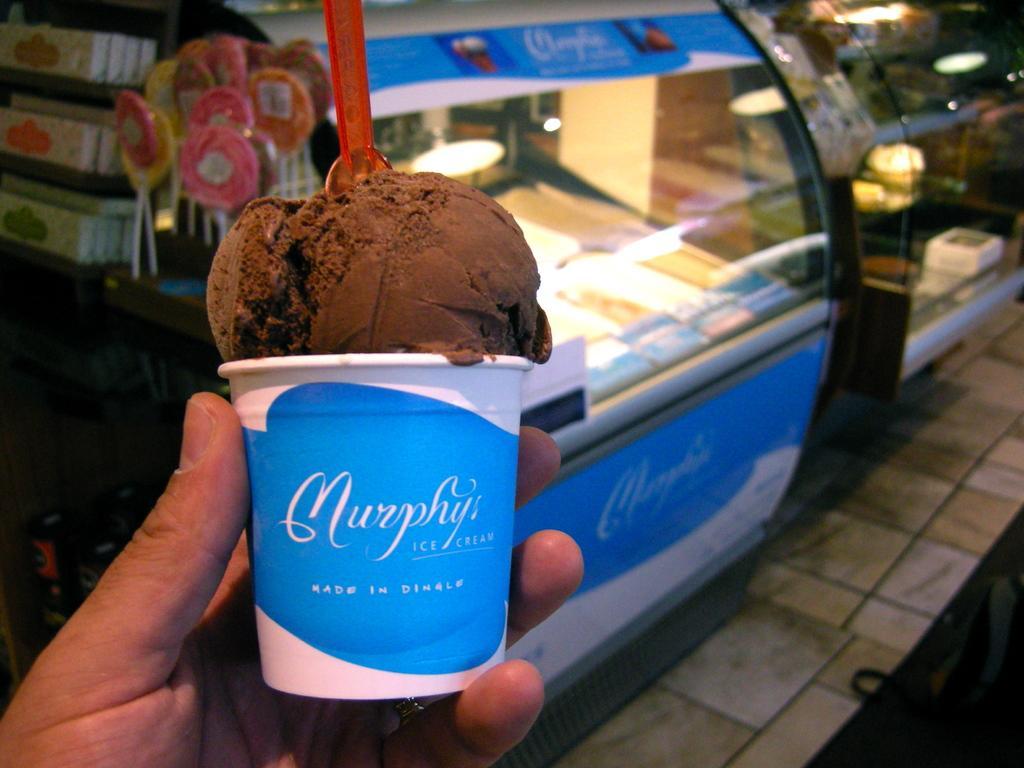How would you summarize this image in a sentence or two? In this image we can see some person holding an ice cream. In the background we can see some food item placed in a glass shelf. We can also see some lollipops on the left. Floor is also visible. 